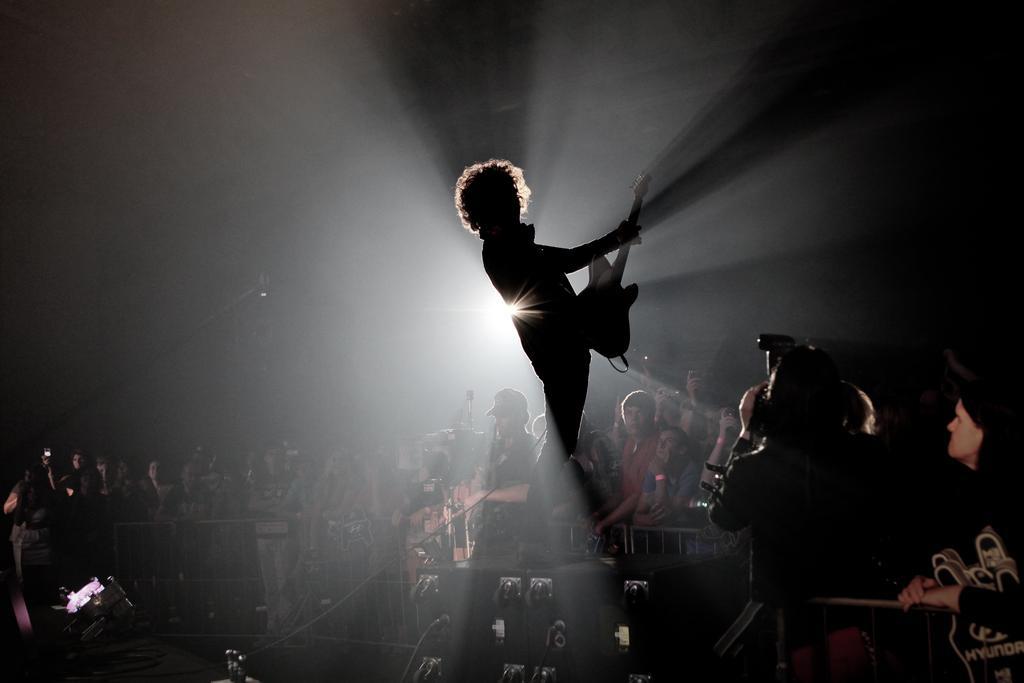Could you give a brief overview of what you see in this image? In the center of the image we can see one person is standing on the black color object. And he is holding a guitar. On the right side of the image we can see a few people are standing and they are holding some objects. In the background, we can see the lights, fences, few people are standing, few people are holding some objects and a few other objects. 